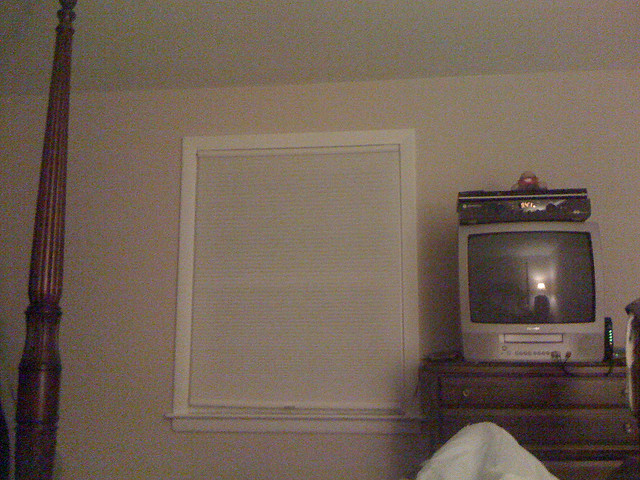<image>What is the object hanging from the window? I don't know what object is hanging from the window. It might be blinds or a shade. What time is this? The time is unknown as it is not clearly specified. It could be nighttime or a specific hour such as 8:41 pm or 9:41, but it's not certain. What is the object hanging from the window? I am not sure what object is hanging from the window. But it can be seen blinds, shade or curtain. What time is this? I don't know what time it is. It can be night or 8:41 pm. 